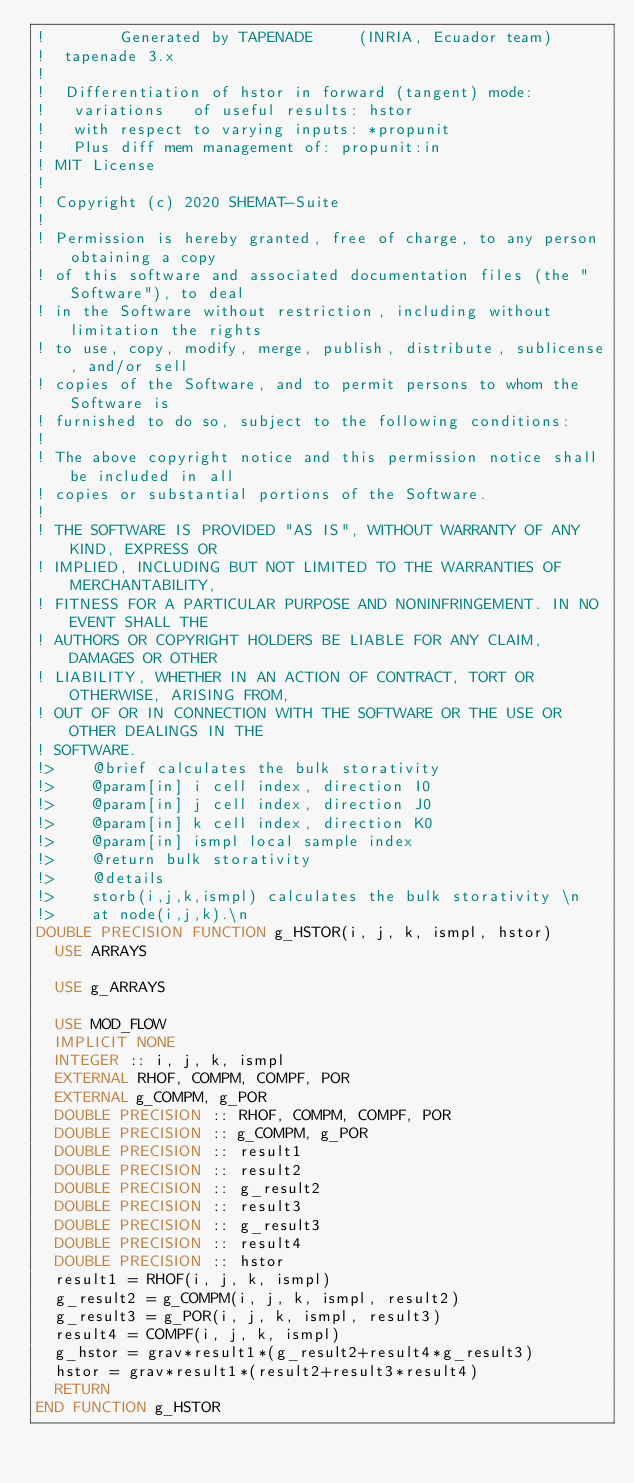<code> <loc_0><loc_0><loc_500><loc_500><_FORTRAN_>!        Generated by TAPENADE     (INRIA, Ecuador team)
!  tapenade 3.x
!
!  Differentiation of hstor in forward (tangent) mode:
!   variations   of useful results: hstor
!   with respect to varying inputs: *propunit
!   Plus diff mem management of: propunit:in
! MIT License
!
! Copyright (c) 2020 SHEMAT-Suite
!
! Permission is hereby granted, free of charge, to any person obtaining a copy
! of this software and associated documentation files (the "Software"), to deal
! in the Software without restriction, including without limitation the rights
! to use, copy, modify, merge, publish, distribute, sublicense, and/or sell
! copies of the Software, and to permit persons to whom the Software is
! furnished to do so, subject to the following conditions:
!
! The above copyright notice and this permission notice shall be included in all
! copies or substantial portions of the Software.
!
! THE SOFTWARE IS PROVIDED "AS IS", WITHOUT WARRANTY OF ANY KIND, EXPRESS OR
! IMPLIED, INCLUDING BUT NOT LIMITED TO THE WARRANTIES OF MERCHANTABILITY,
! FITNESS FOR A PARTICULAR PURPOSE AND NONINFRINGEMENT. IN NO EVENT SHALL THE
! AUTHORS OR COPYRIGHT HOLDERS BE LIABLE FOR ANY CLAIM, DAMAGES OR OTHER
! LIABILITY, WHETHER IN AN ACTION OF CONTRACT, TORT OR OTHERWISE, ARISING FROM,
! OUT OF OR IN CONNECTION WITH THE SOFTWARE OR THE USE OR OTHER DEALINGS IN THE
! SOFTWARE.
!>    @brief calculates the bulk storativity
!>    @param[in] i cell index, direction I0
!>    @param[in] j cell index, direction J0
!>    @param[in] k cell index, direction K0
!>    @param[in] ismpl local sample index
!>    @return bulk storativity
!>    @details
!>    storb(i,j,k,ismpl) calculates the bulk storativity \n
!>    at node(i,j,k).\n
DOUBLE PRECISION FUNCTION g_HSTOR(i, j, k, ismpl, hstor)
  USE ARRAYS

  USE g_ARRAYS

  USE MOD_FLOW
  IMPLICIT NONE
  INTEGER :: i, j, k, ismpl
  EXTERNAL RHOF, COMPM, COMPF, POR
  EXTERNAL g_COMPM, g_POR
  DOUBLE PRECISION :: RHOF, COMPM, COMPF, POR
  DOUBLE PRECISION :: g_COMPM, g_POR
  DOUBLE PRECISION :: result1
  DOUBLE PRECISION :: result2
  DOUBLE PRECISION :: g_result2
  DOUBLE PRECISION :: result3
  DOUBLE PRECISION :: g_result3
  DOUBLE PRECISION :: result4
  DOUBLE PRECISION :: hstor
  result1 = RHOF(i, j, k, ismpl)
  g_result2 = g_COMPM(i, j, k, ismpl, result2)
  g_result3 = g_POR(i, j, k, ismpl, result3)
  result4 = COMPF(i, j, k, ismpl)
  g_hstor = grav*result1*(g_result2+result4*g_result3)
  hstor = grav*result1*(result2+result3*result4)
  RETURN
END FUNCTION g_HSTOR

</code> 